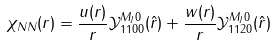<formula> <loc_0><loc_0><loc_500><loc_500>\chi _ { N N } ( { r } ) = \frac { u ( r ) } { r } \mathcal { Y } _ { 1 1 0 0 } ^ { M _ { J } 0 } ( \hat { r } ) + \frac { w ( r ) } { r } \mathcal { Y } _ { 1 1 2 0 } ^ { M _ { J } 0 } ( \hat { r } )</formula> 